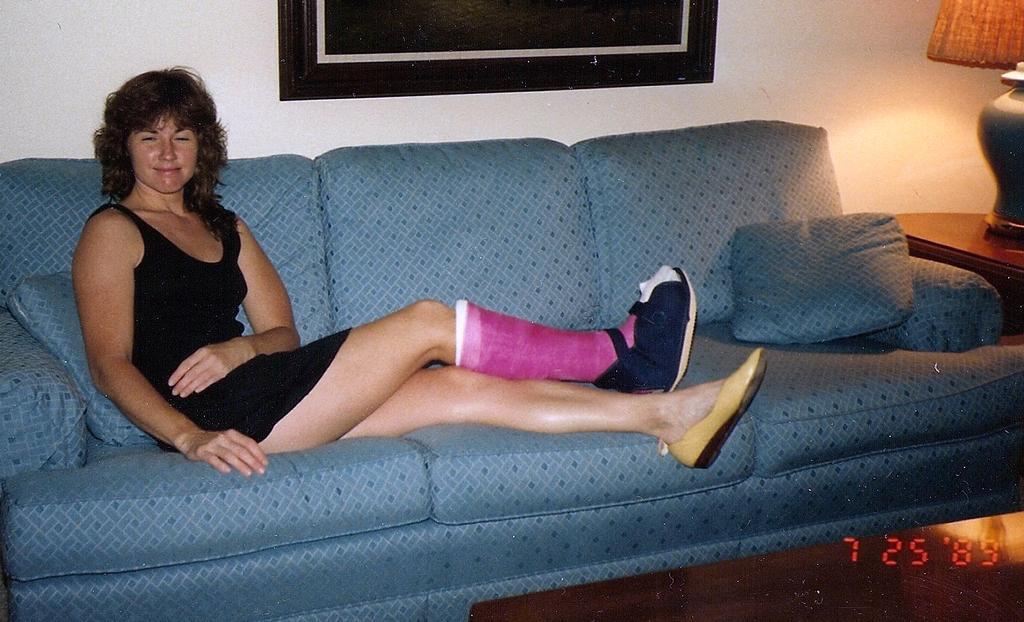How would you summarize this image in a sentence or two? This picture is of inside. In the center there is a woman wearing a black color dress and sitting on the couch. On the right there is a lamp placed on the top of the table. In the background we can see a wall and a picture frame hanging on the wall. 